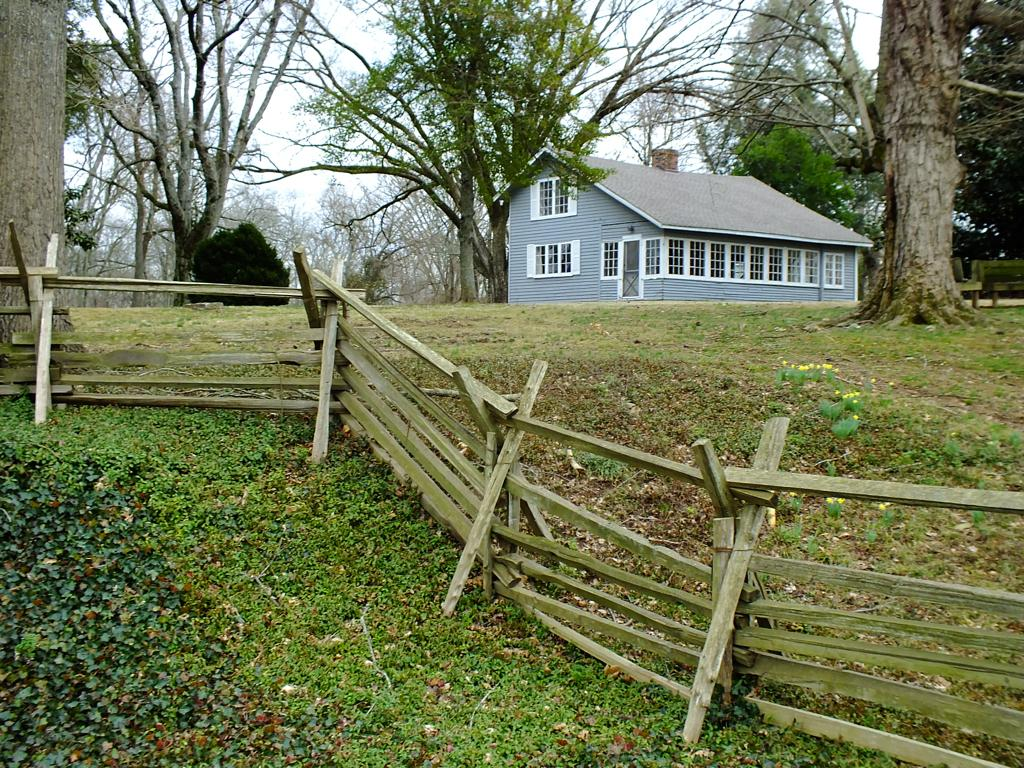What type of structure is present in the image? There is a house in the image. What features can be seen on the house? The house has windows and a door. What else is visible in the image besides the house? There are trees, wooden fencing, and plants on the ground in the image. What can be seen in the background of the image? The sky is visible in the background of the image. How many heads of cabbage are growing in the image? There is no cabbage present in the image; it features a house, trees, wooden fencing, and plants on the ground. What time of day is it in the image? The provided facts do not give any information about the time of day in the image. 